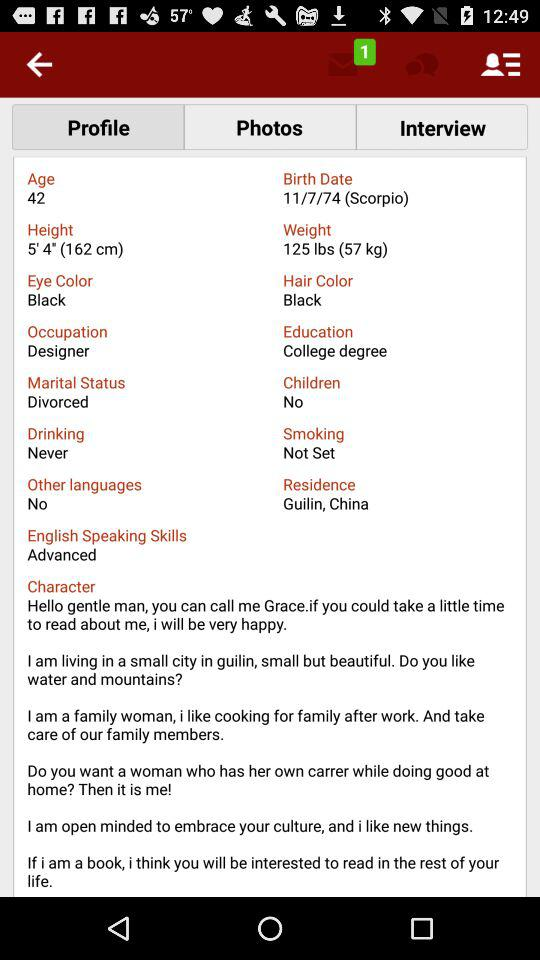What is the marital status? The marital status is divorced. 